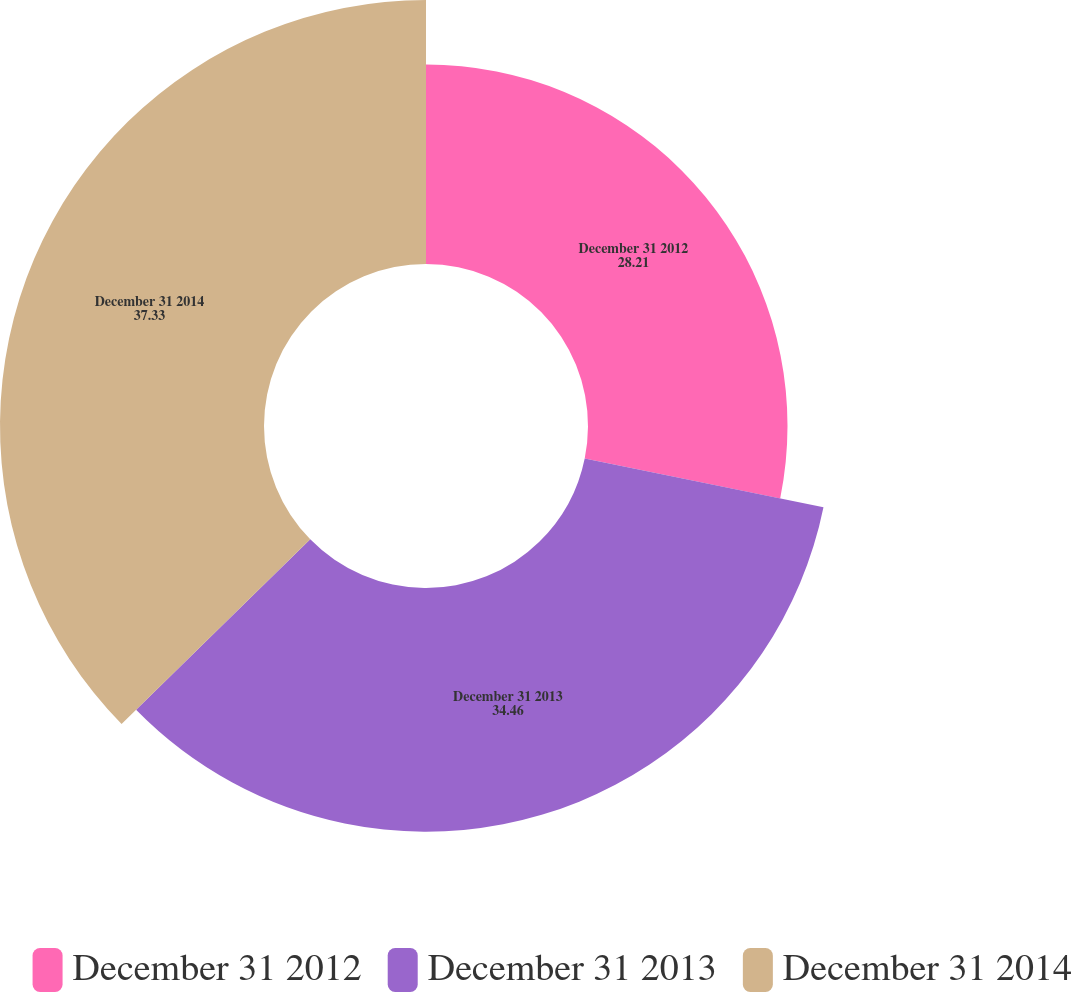<chart> <loc_0><loc_0><loc_500><loc_500><pie_chart><fcel>December 31 2012<fcel>December 31 2013<fcel>December 31 2014<nl><fcel>28.21%<fcel>34.46%<fcel>37.33%<nl></chart> 